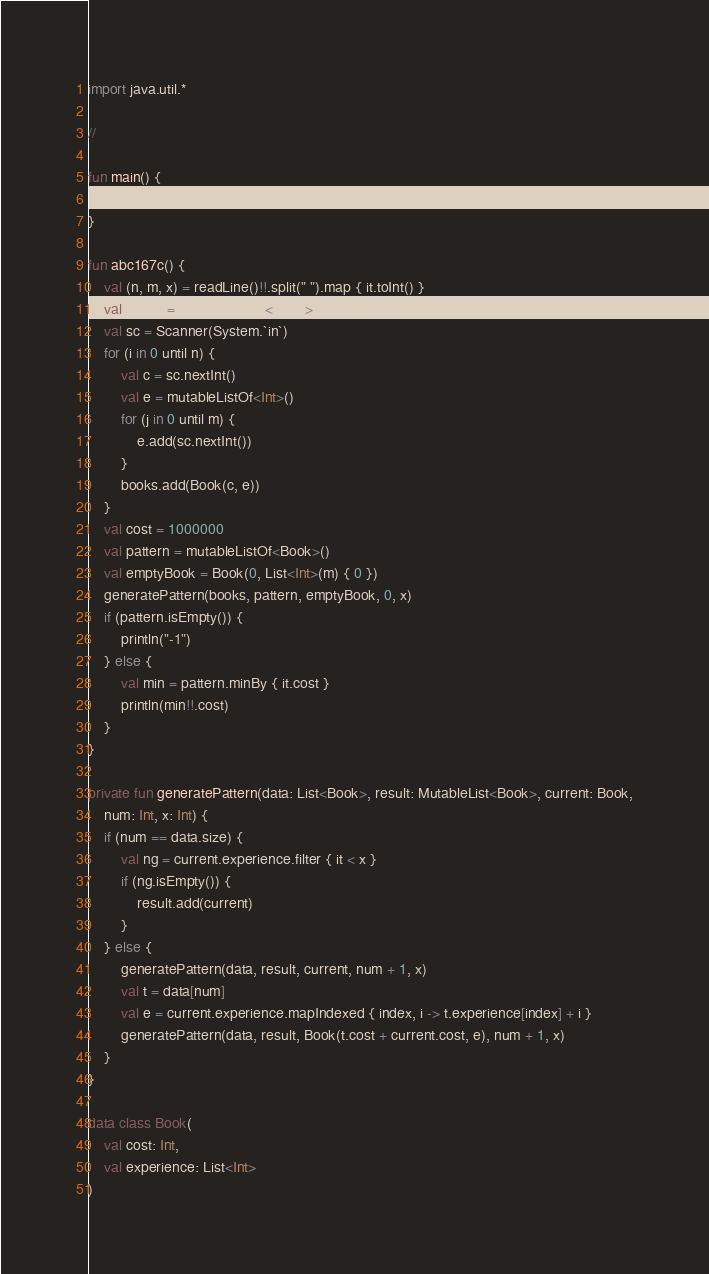<code> <loc_0><loc_0><loc_500><loc_500><_Kotlin_>import java.util.*

//

fun main() {
    abc167c()
}

fun abc167c() {
    val (n, m, x) = readLine()!!.split(" ").map { it.toInt() }
    val books = mutableListOf<Book>()
    val sc = Scanner(System.`in`)
    for (i in 0 until n) {
        val c = sc.nextInt()
        val e = mutableListOf<Int>()
        for (j in 0 until m) {
            e.add(sc.nextInt())
        }
        books.add(Book(c, e))
    }
    val cost = 1000000
    val pattern = mutableListOf<Book>()
    val emptyBook = Book(0, List<Int>(m) { 0 })
    generatePattern(books, pattern, emptyBook, 0, x)
    if (pattern.isEmpty()) {
        println("-1")
    } else {
        val min = pattern.minBy { it.cost }
        println(min!!.cost)
    }
}

private fun generatePattern(data: List<Book>, result: MutableList<Book>, current: Book,
    num: Int, x: Int) {
    if (num == data.size) {
        val ng = current.experience.filter { it < x }
        if (ng.isEmpty()) {
            result.add(current)
        }
    } else {
        generatePattern(data, result, current, num + 1, x)
        val t = data[num]
        val e = current.experience.mapIndexed { index, i -> t.experience[index] + i }
        generatePattern(data, result, Book(t.cost + current.cost, e), num + 1, x)
    }
}

data class Book(
    val cost: Int,
    val experience: List<Int>
)</code> 